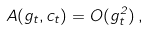Convert formula to latex. <formula><loc_0><loc_0><loc_500><loc_500>A ( g _ { t } , c _ { t } ) = O ( g _ { t } ^ { 2 } ) \, ,</formula> 